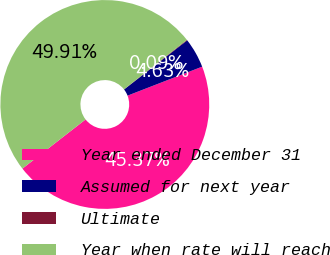Convert chart. <chart><loc_0><loc_0><loc_500><loc_500><pie_chart><fcel>Year ended December 31<fcel>Assumed for next year<fcel>Ultimate<fcel>Year when rate will reach<nl><fcel>45.37%<fcel>4.63%<fcel>0.09%<fcel>49.91%<nl></chart> 